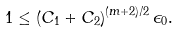Convert formula to latex. <formula><loc_0><loc_0><loc_500><loc_500>1 \leq \left ( C _ { 1 } + C _ { 2 } \right ) ^ { ( m + 2 ) / 2 } \epsilon _ { 0 } .</formula> 